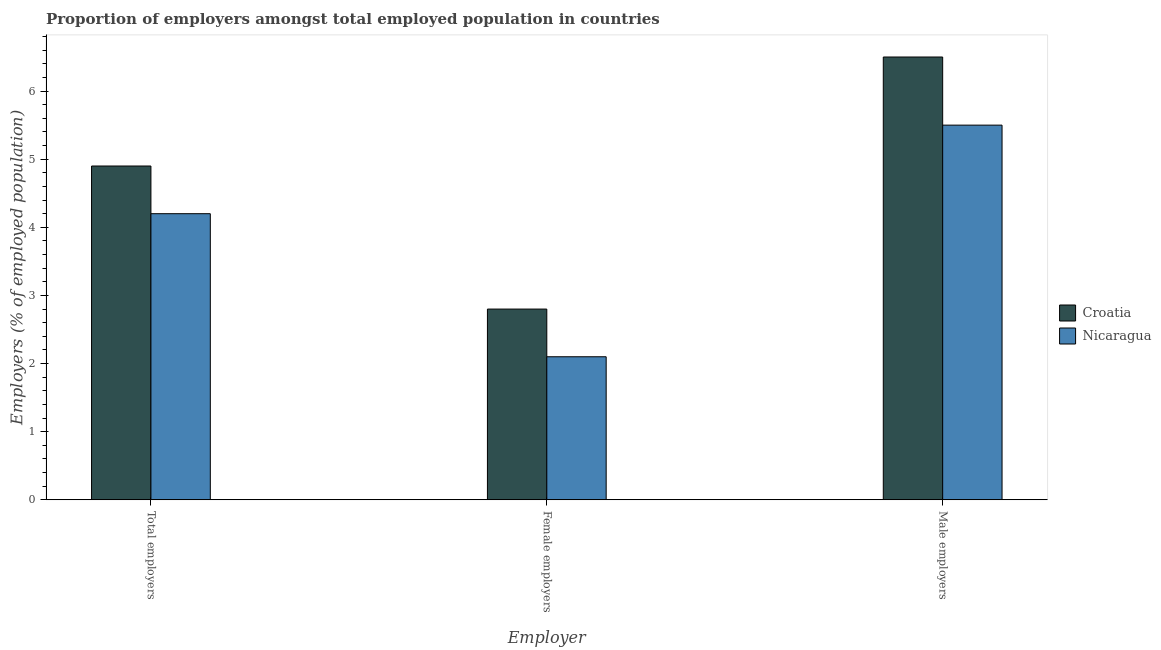How many different coloured bars are there?
Make the answer very short. 2. Are the number of bars per tick equal to the number of legend labels?
Your answer should be compact. Yes. Are the number of bars on each tick of the X-axis equal?
Offer a terse response. Yes. What is the label of the 3rd group of bars from the left?
Ensure brevity in your answer.  Male employers. What is the percentage of female employers in Croatia?
Offer a terse response. 2.8. Across all countries, what is the maximum percentage of female employers?
Your answer should be compact. 2.8. Across all countries, what is the minimum percentage of total employers?
Your answer should be very brief. 4.2. In which country was the percentage of male employers maximum?
Make the answer very short. Croatia. In which country was the percentage of male employers minimum?
Ensure brevity in your answer.  Nicaragua. What is the total percentage of female employers in the graph?
Your answer should be very brief. 4.9. What is the difference between the percentage of male employers in Croatia and the percentage of total employers in Nicaragua?
Make the answer very short. 2.3. What is the average percentage of female employers per country?
Offer a very short reply. 2.45. What is the difference between the percentage of female employers and percentage of male employers in Croatia?
Ensure brevity in your answer.  -3.7. In how many countries, is the percentage of total employers greater than 3.2 %?
Your response must be concise. 2. What is the ratio of the percentage of total employers in Croatia to that in Nicaragua?
Your answer should be compact. 1.17. Is the difference between the percentage of male employers in Nicaragua and Croatia greater than the difference between the percentage of total employers in Nicaragua and Croatia?
Provide a succinct answer. No. What is the difference between the highest and the second highest percentage of female employers?
Ensure brevity in your answer.  0.7. What does the 2nd bar from the left in Male employers represents?
Provide a succinct answer. Nicaragua. What does the 1st bar from the right in Female employers represents?
Offer a terse response. Nicaragua. What is the difference between two consecutive major ticks on the Y-axis?
Your answer should be compact. 1. Are the values on the major ticks of Y-axis written in scientific E-notation?
Offer a terse response. No. How are the legend labels stacked?
Provide a succinct answer. Vertical. What is the title of the graph?
Keep it short and to the point. Proportion of employers amongst total employed population in countries. What is the label or title of the X-axis?
Provide a succinct answer. Employer. What is the label or title of the Y-axis?
Give a very brief answer. Employers (% of employed population). What is the Employers (% of employed population) in Croatia in Total employers?
Offer a very short reply. 4.9. What is the Employers (% of employed population) of Nicaragua in Total employers?
Offer a terse response. 4.2. What is the Employers (% of employed population) in Croatia in Female employers?
Offer a very short reply. 2.8. What is the Employers (% of employed population) in Nicaragua in Female employers?
Provide a succinct answer. 2.1. What is the Employers (% of employed population) in Croatia in Male employers?
Keep it short and to the point. 6.5. What is the Employers (% of employed population) of Nicaragua in Male employers?
Give a very brief answer. 5.5. Across all Employer, what is the maximum Employers (% of employed population) in Croatia?
Make the answer very short. 6.5. Across all Employer, what is the maximum Employers (% of employed population) in Nicaragua?
Provide a succinct answer. 5.5. Across all Employer, what is the minimum Employers (% of employed population) of Croatia?
Keep it short and to the point. 2.8. Across all Employer, what is the minimum Employers (% of employed population) of Nicaragua?
Give a very brief answer. 2.1. What is the total Employers (% of employed population) in Croatia in the graph?
Provide a short and direct response. 14.2. What is the total Employers (% of employed population) of Nicaragua in the graph?
Your answer should be compact. 11.8. What is the difference between the Employers (% of employed population) of Nicaragua in Total employers and that in Female employers?
Your answer should be compact. 2.1. What is the difference between the Employers (% of employed population) in Croatia in Female employers and that in Male employers?
Provide a succinct answer. -3.7. What is the difference between the Employers (% of employed population) of Croatia in Total employers and the Employers (% of employed population) of Nicaragua in Male employers?
Provide a succinct answer. -0.6. What is the difference between the Employers (% of employed population) of Croatia in Female employers and the Employers (% of employed population) of Nicaragua in Male employers?
Give a very brief answer. -2.7. What is the average Employers (% of employed population) in Croatia per Employer?
Keep it short and to the point. 4.73. What is the average Employers (% of employed population) of Nicaragua per Employer?
Give a very brief answer. 3.93. What is the difference between the Employers (% of employed population) in Croatia and Employers (% of employed population) in Nicaragua in Male employers?
Offer a very short reply. 1. What is the ratio of the Employers (% of employed population) of Croatia in Total employers to that in Male employers?
Offer a terse response. 0.75. What is the ratio of the Employers (% of employed population) in Nicaragua in Total employers to that in Male employers?
Keep it short and to the point. 0.76. What is the ratio of the Employers (% of employed population) in Croatia in Female employers to that in Male employers?
Your answer should be very brief. 0.43. What is the ratio of the Employers (% of employed population) in Nicaragua in Female employers to that in Male employers?
Your answer should be compact. 0.38. What is the difference between the highest and the lowest Employers (% of employed population) in Croatia?
Your answer should be very brief. 3.7. 